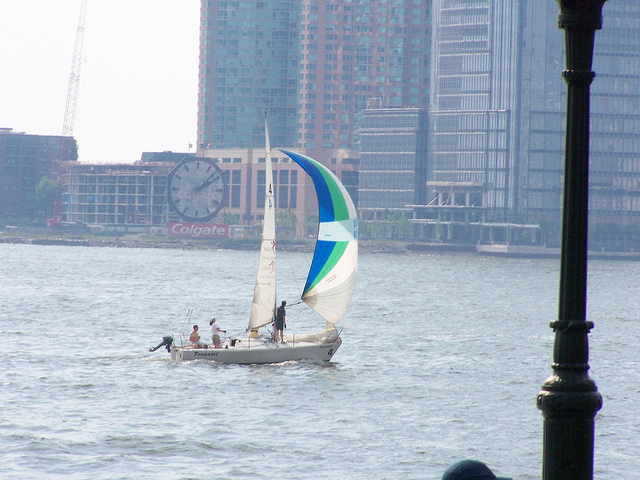Can you tell me about the large clock in the background? Certainly! The large clock in the background is a notable landmark, adding character to the urban skyline. It's an oversized, circular timepiece that is easily visible from a distance, suggesting it serves not just as a functional item but also as an architectural feature, possibly intended for the benefit of the local community and those on the water to easily tell the time. 